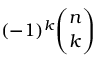<formula> <loc_0><loc_0><loc_500><loc_500>( - 1 ) ^ { k } { \binom { n } { k } }</formula> 